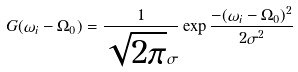Convert formula to latex. <formula><loc_0><loc_0><loc_500><loc_500>G ( \omega _ { i } - \Omega _ { 0 } ) = \frac { 1 } { \sqrt { 2 \pi } \sigma } \exp \frac { - ( \omega _ { i } - \Omega _ { 0 } ) ^ { 2 } } { 2 \sigma ^ { 2 } }</formula> 